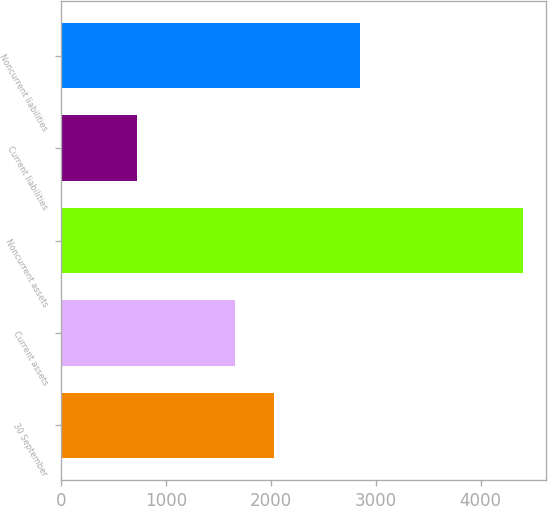<chart> <loc_0><loc_0><loc_500><loc_500><bar_chart><fcel>30 September<fcel>Current assets<fcel>Noncurrent assets<fcel>Current liabilities<fcel>Noncurrent liabilities<nl><fcel>2028.13<fcel>1660.6<fcel>4400.4<fcel>725.1<fcel>2853.6<nl></chart> 